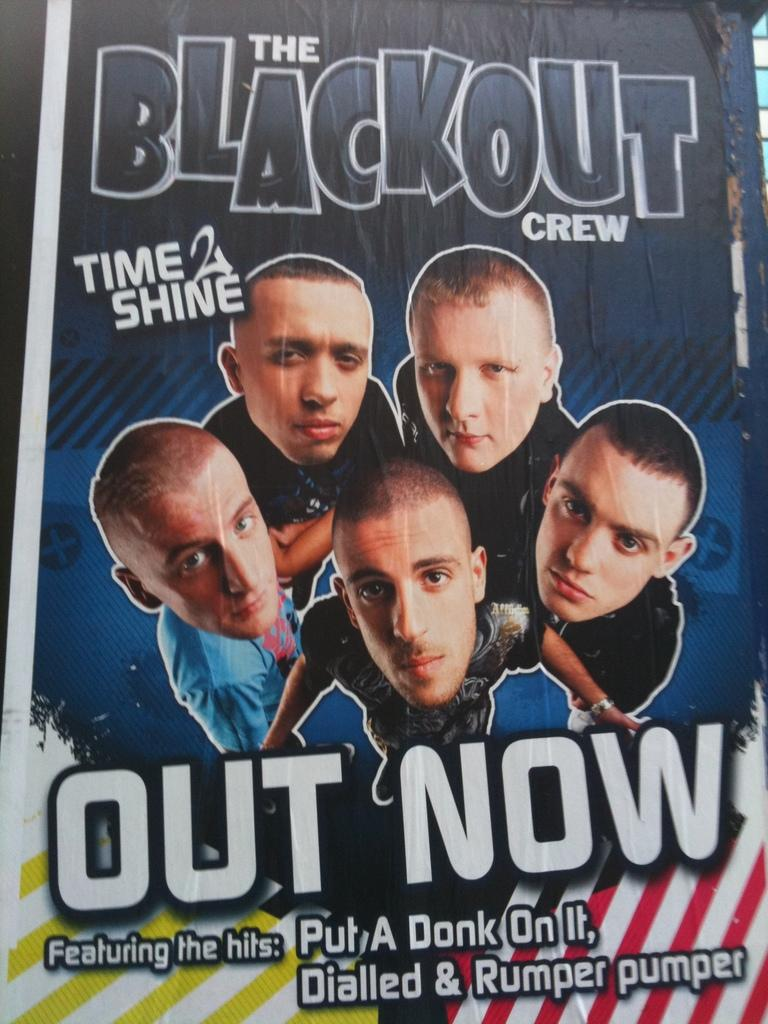What is present in the image? There is a poster in the image. What can be seen on the poster? The poster contains images of five men. Are there any words on the poster? Yes, there is text on the poster. How many eggs are visible on the poster? There are no eggs visible on the poster; it contains images of five men and text. 